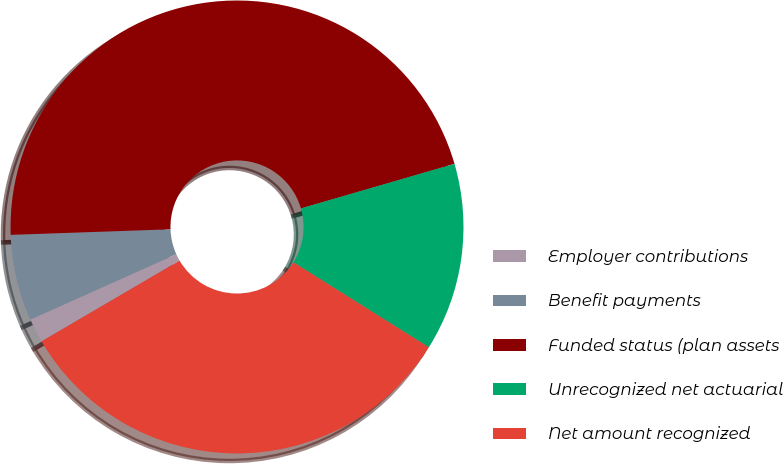Convert chart to OTSL. <chart><loc_0><loc_0><loc_500><loc_500><pie_chart><fcel>Employer contributions<fcel>Benefit payments<fcel>Funded status (plan assets<fcel>Unrecognized net actuarial<fcel>Net amount recognized<nl><fcel>1.72%<fcel>6.15%<fcel>46.06%<fcel>13.41%<fcel>32.66%<nl></chart> 